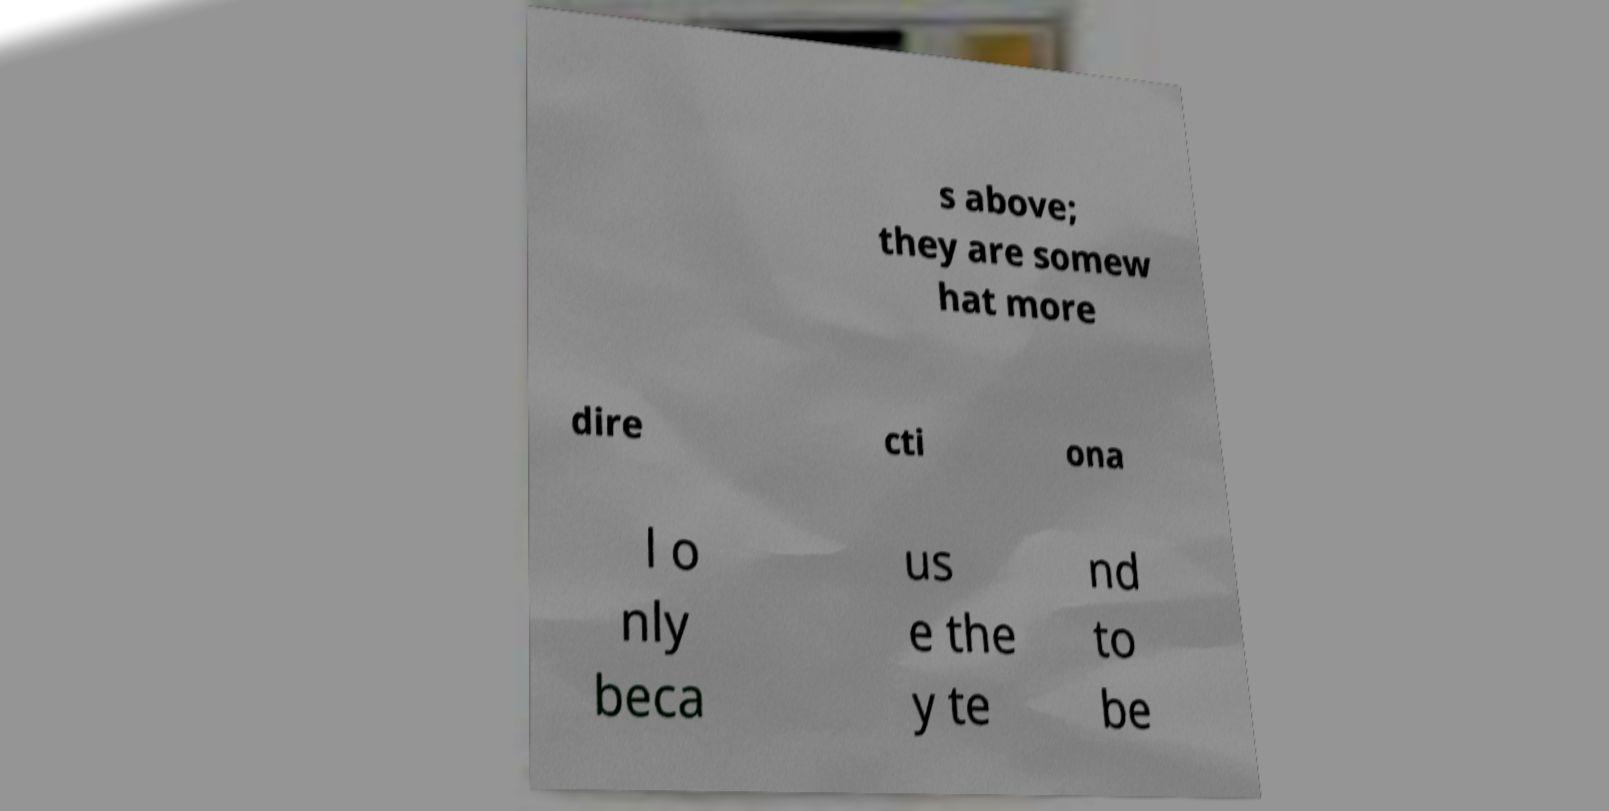Could you extract and type out the text from this image? s above; they are somew hat more dire cti ona l o nly beca us e the y te nd to be 